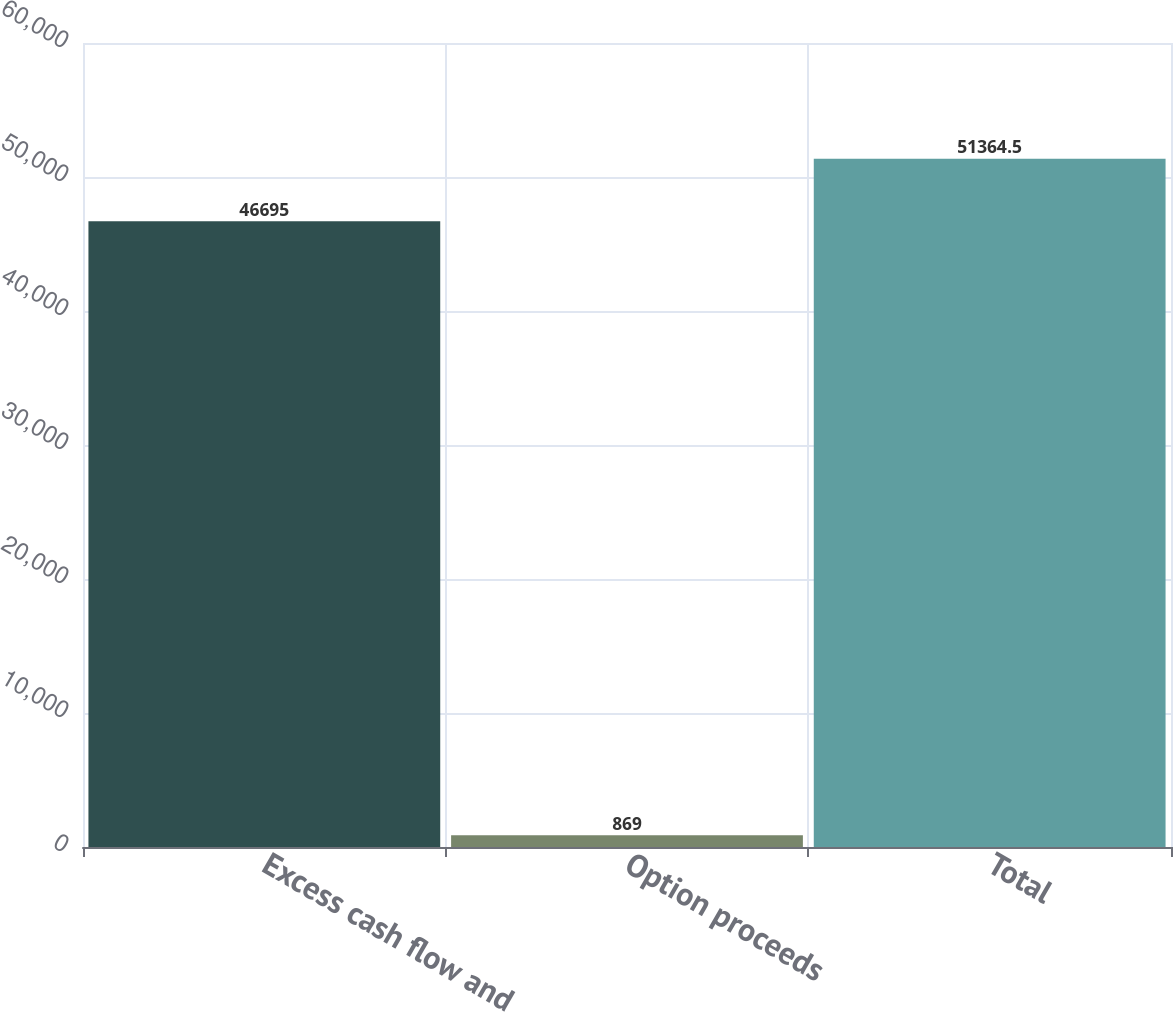<chart> <loc_0><loc_0><loc_500><loc_500><bar_chart><fcel>Excess cash flow and<fcel>Option proceeds<fcel>Total<nl><fcel>46695<fcel>869<fcel>51364.5<nl></chart> 